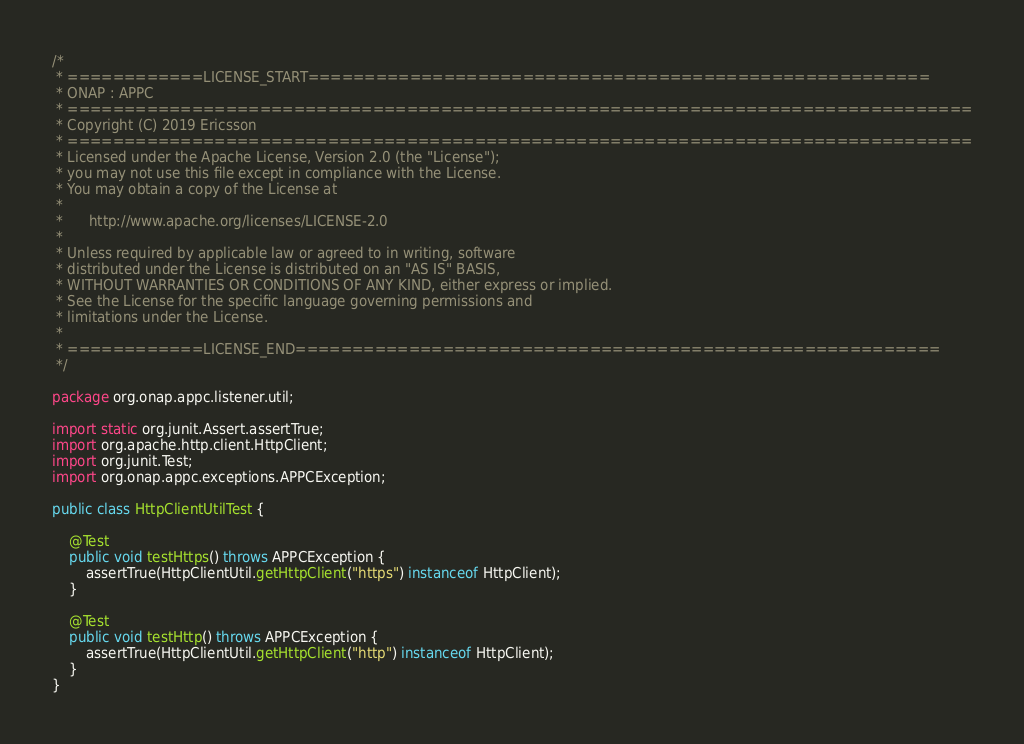Convert code to text. <code><loc_0><loc_0><loc_500><loc_500><_Java_>/*
 * ============LICENSE_START=======================================================
 * ONAP : APPC
 * ================================================================================
 * Copyright (C) 2019 Ericsson
 * ================================================================================
 * Licensed under the Apache License, Version 2.0 (the "License");
 * you may not use this file except in compliance with the License.
 * You may obtain a copy of the License at
 *
 *      http://www.apache.org/licenses/LICENSE-2.0
 *
 * Unless required by applicable law or agreed to in writing, software
 * distributed under the License is distributed on an "AS IS" BASIS,
 * WITHOUT WARRANTIES OR CONDITIONS OF ANY KIND, either express or implied.
 * See the License for the specific language governing permissions and
 * limitations under the License.
 *
 * ============LICENSE_END=========================================================
 */

package org.onap.appc.listener.util;

import static org.junit.Assert.assertTrue;
import org.apache.http.client.HttpClient;
import org.junit.Test;
import org.onap.appc.exceptions.APPCException;

public class HttpClientUtilTest {

    @Test
    public void testHttps() throws APPCException {
        assertTrue(HttpClientUtil.getHttpClient("https") instanceof HttpClient);
    }

    @Test
    public void testHttp() throws APPCException {
        assertTrue(HttpClientUtil.getHttpClient("http") instanceof HttpClient);
    }
}
</code> 